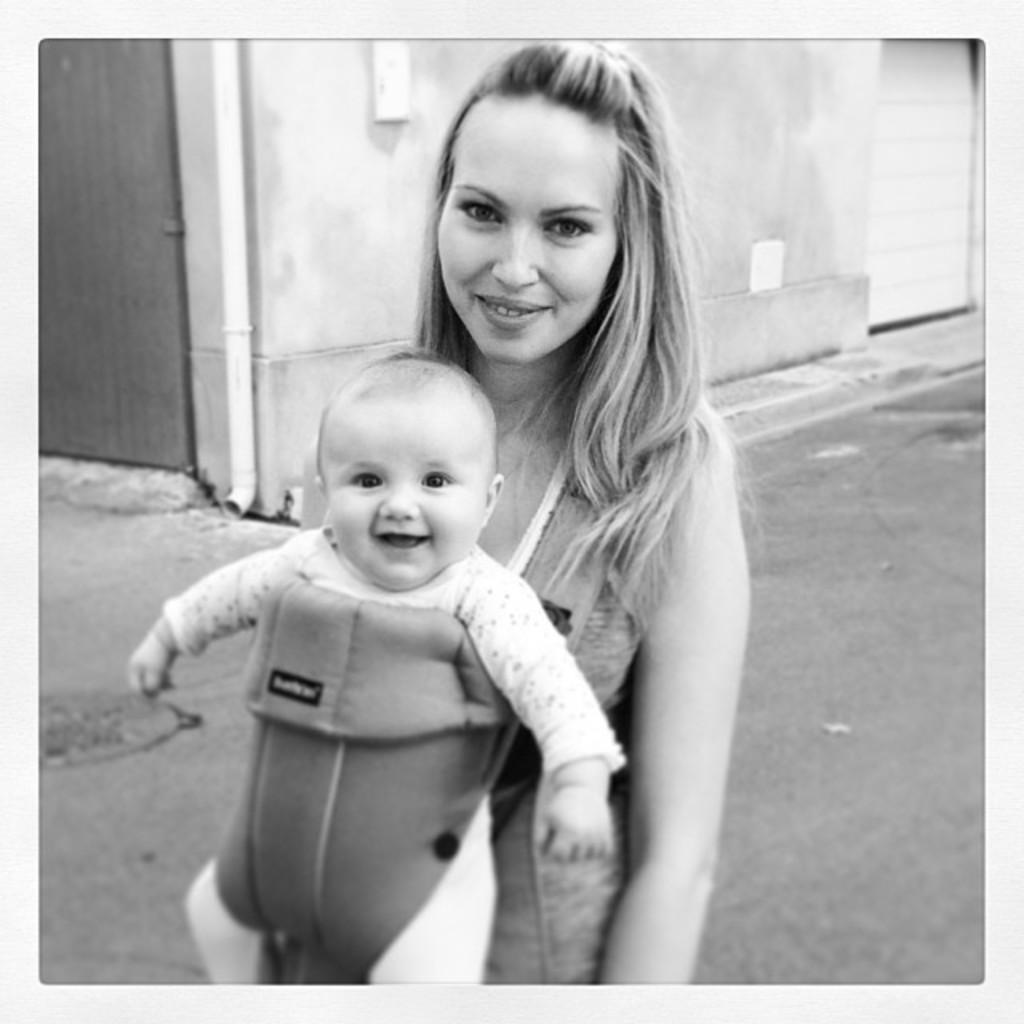Describe this image in one or two sentences. In this image we can see one building, one pole, two objects attached to the wall, two doors, one woman standing on the road and carrying a baby. 